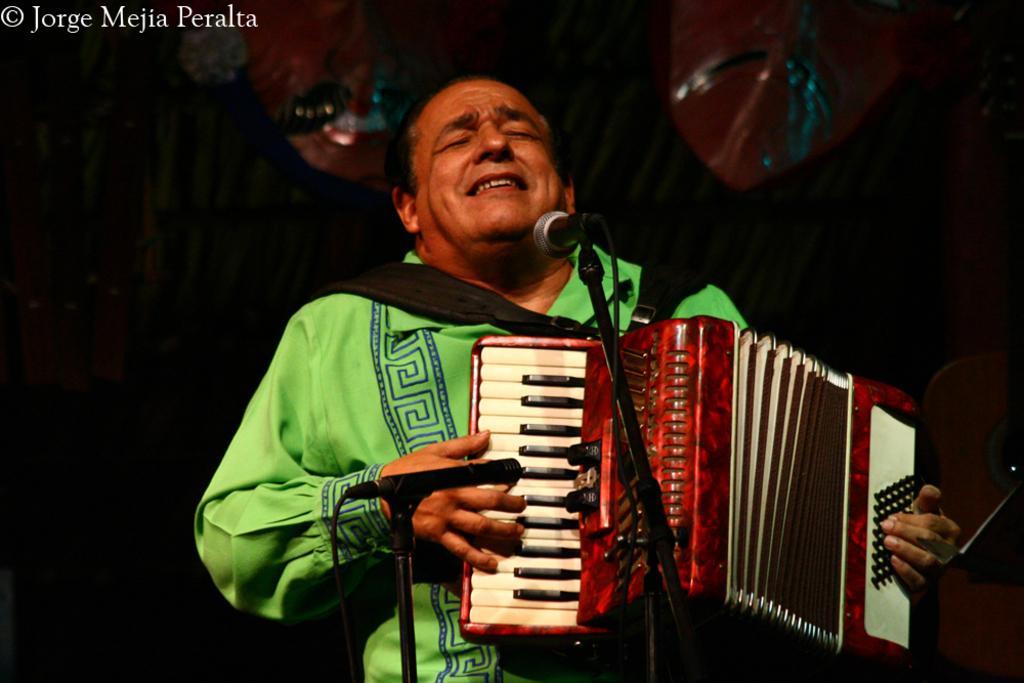How would you summarize this image in a sentence or two? In this image we can see a man standing by holding musical instrument in his hands and mics are placed in front of him. In the background there is a curtain and decors to it. 